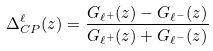Convert formula to latex. <formula><loc_0><loc_0><loc_500><loc_500>\Delta _ { C P } ^ { \ell } ( z ) = \frac { G _ { \ell ^ { + } } ( z ) - G _ { \ell ^ { - } } ( z ) } { G _ { \ell ^ { + } } ( z ) + G _ { \ell ^ { - } } ( z ) } \,</formula> 